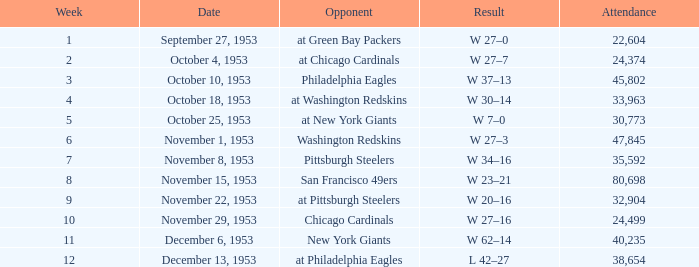What is the largest crowd size at a match against the Chicago Cardinals after Week 10 of the season? None. 